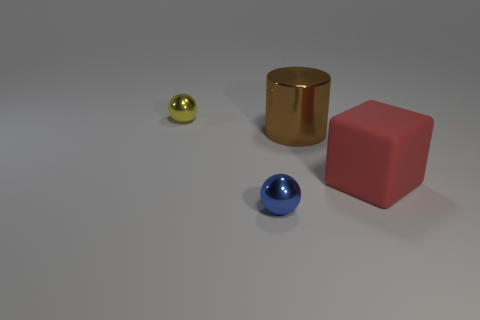What objects can be seen in the image, and what are their colors and shapes? The image presents four distinct objects: a blue glossy sphere, a gold metallic cylinder, a small yellow metallic sphere, and a large pink matte cube. They are situated on what appears to be a light gray surface, likely to emphasize the varying colors and forms of the objects. 